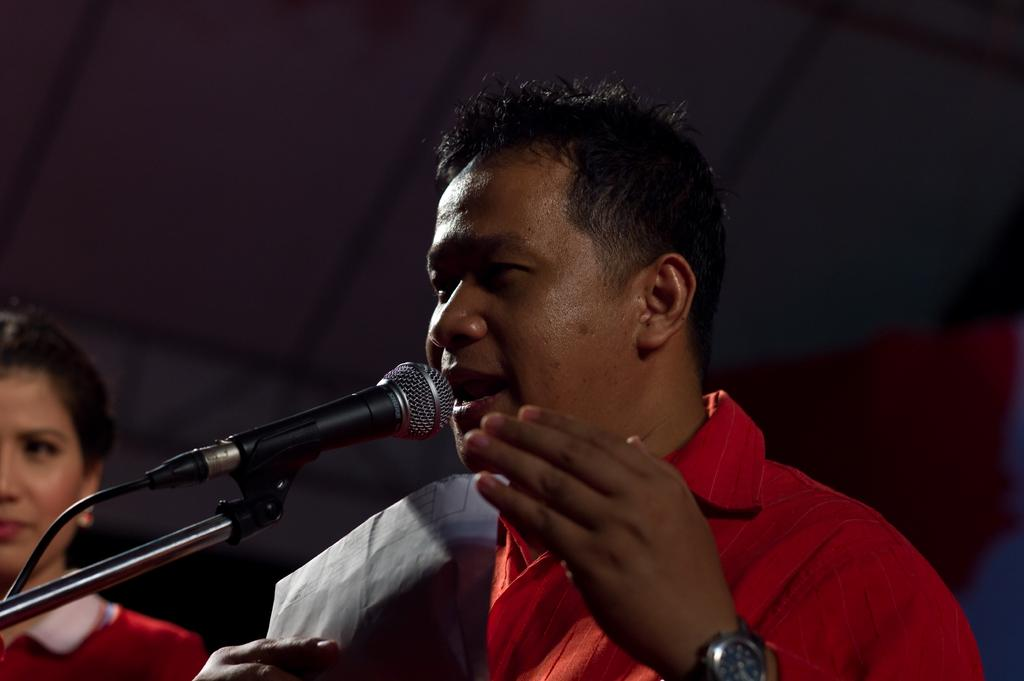Who is the main subject in the center of the image? There is a man in the center of the image. What is the man holding in the image? The man is holding a paper. What object is in front of the man that might be used for amplifying his voice? There is a microphone on a stand in front of the man. Who is the other person visible in the image? There is a lady on the left side of the image. What is the fear of the man in the image? There is no indication of fear in the image; the man is holding a paper and standing near a microphone. How many children were born during the event in the image? There is no event or mention of births in the image; it features a man holding a paper and a lady on the left side. 